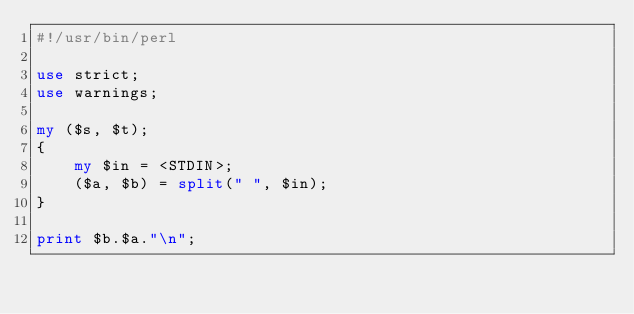<code> <loc_0><loc_0><loc_500><loc_500><_Perl_>#!/usr/bin/perl

use strict;
use warnings;

my ($s, $t);
{
    my $in = <STDIN>;
    ($a, $b) = split(" ", $in);
}

print $b.$a."\n";</code> 